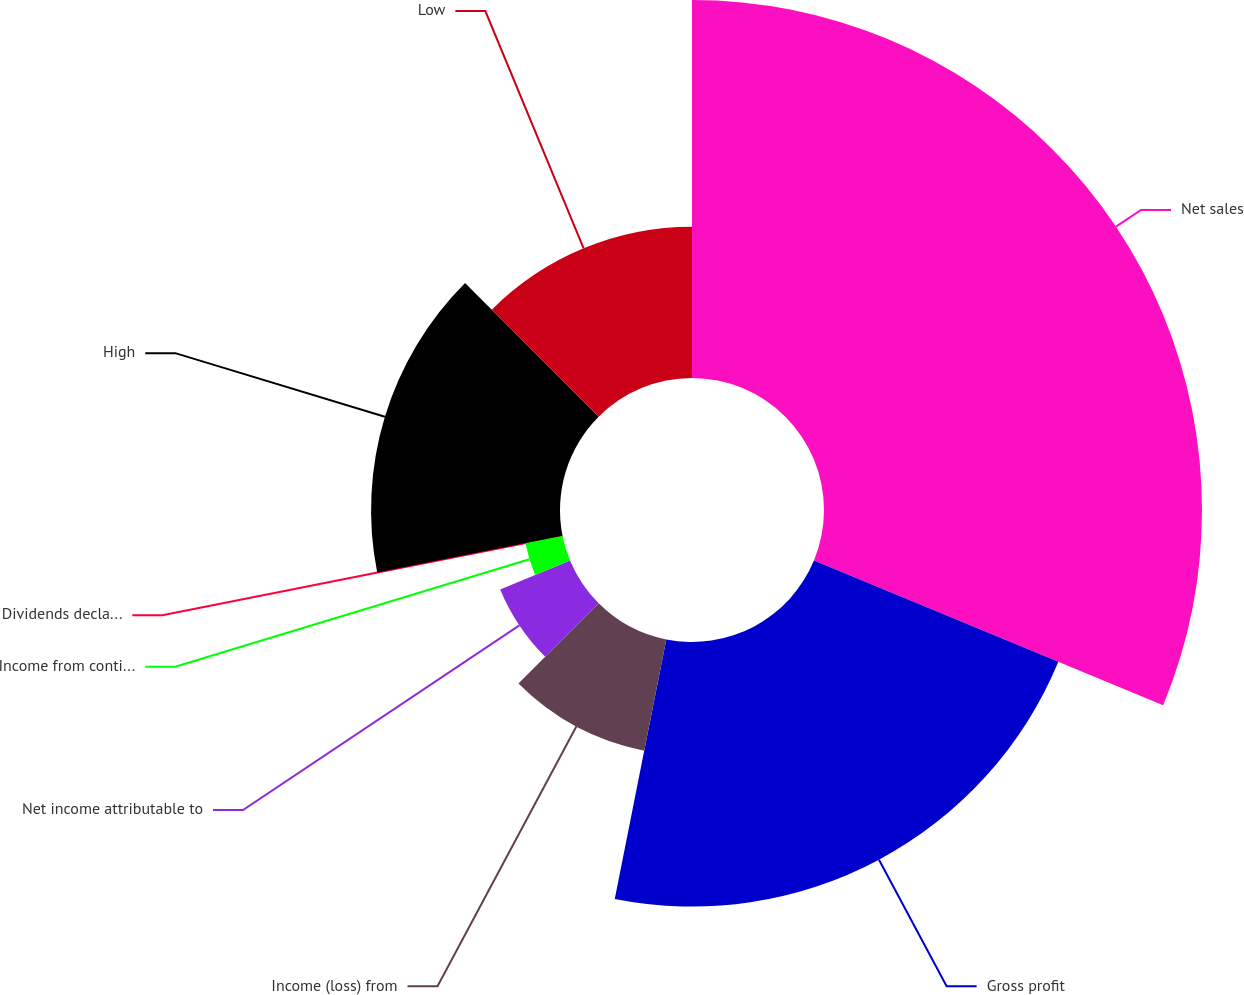Convert chart. <chart><loc_0><loc_0><loc_500><loc_500><pie_chart><fcel>Net sales<fcel>Gross profit<fcel>Income (loss) from<fcel>Net income attributable to<fcel>Income from continuing<fcel>Dividends declared per common<fcel>High<fcel>Low<nl><fcel>31.25%<fcel>21.87%<fcel>9.38%<fcel>6.25%<fcel>3.13%<fcel>0.0%<fcel>15.62%<fcel>12.5%<nl></chart> 